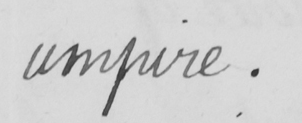What text is written in this handwritten line? umpire . 